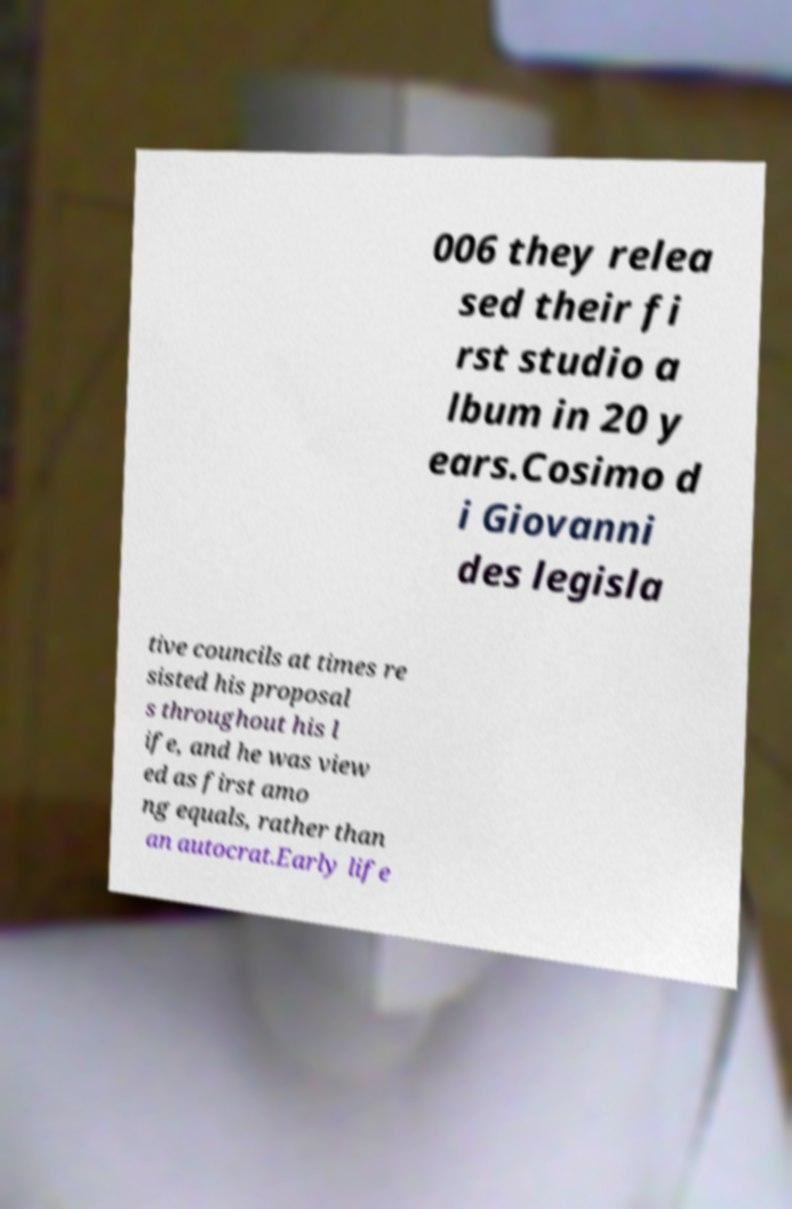Please read and relay the text visible in this image. What does it say? 006 they relea sed their fi rst studio a lbum in 20 y ears.Cosimo d i Giovanni des legisla tive councils at times re sisted his proposal s throughout his l ife, and he was view ed as first amo ng equals, rather than an autocrat.Early life 